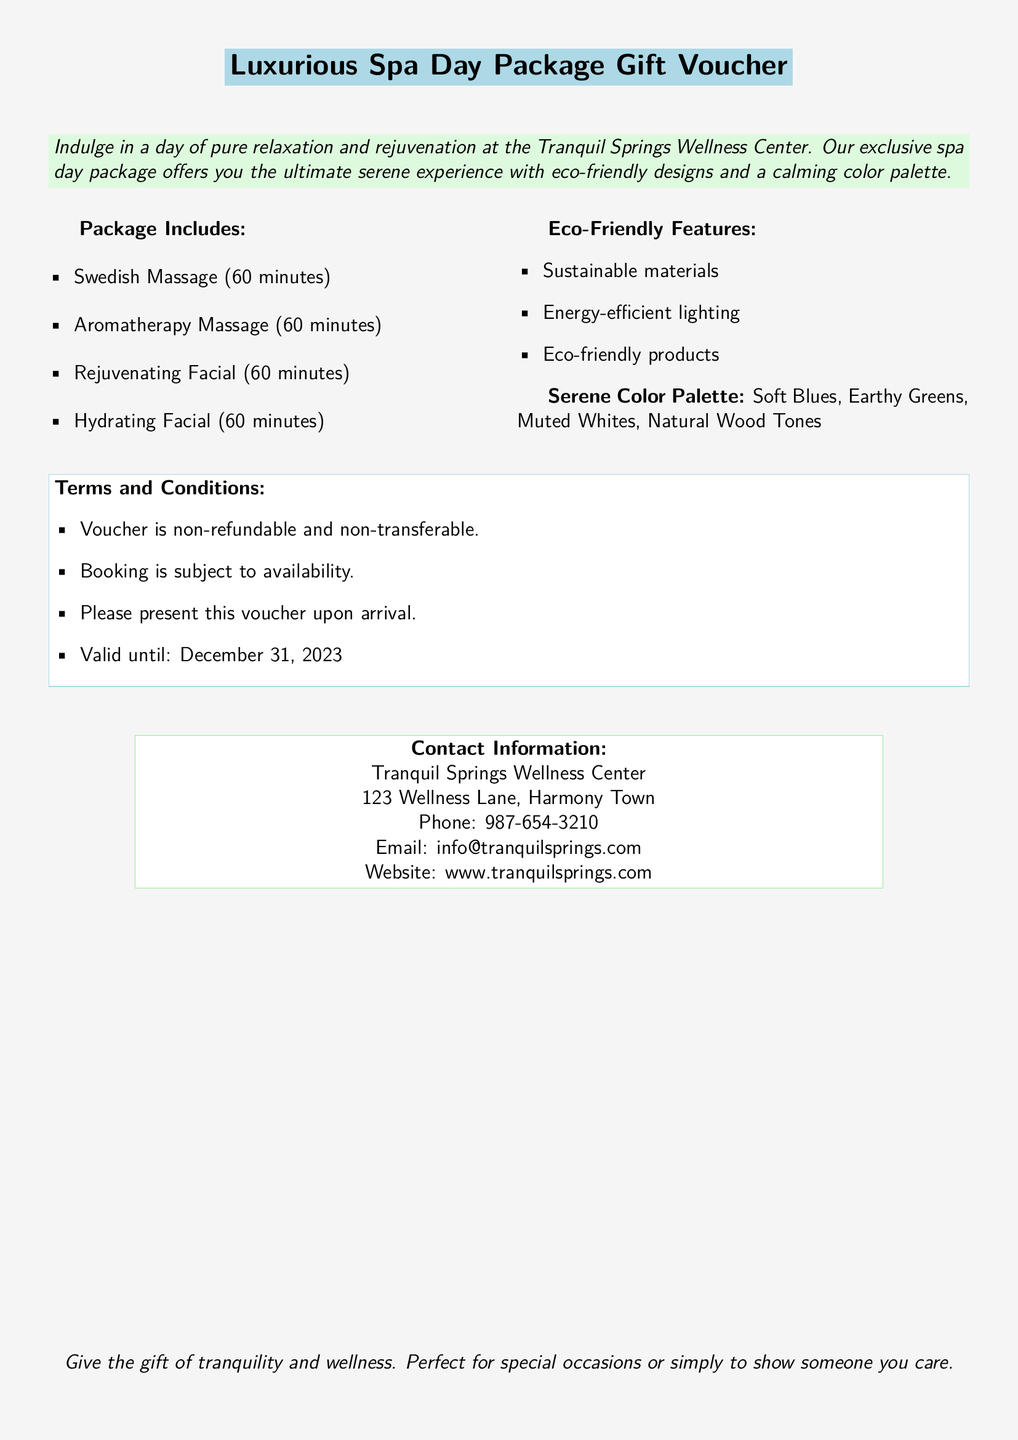What is the title of the voucher? The title of the voucher is clearly stated at the top of the document in large font.
Answer: Luxurious Spa Day Package Gift Voucher What is the valid until date? The document specifies the expiry date for the voucher in the terms and conditions section.
Answer: December 31, 2023 How long is the Swedish Massage? The duration of each massage is listed under the package includes section.
Answer: 60 minutes What eco-friendly feature is mentioned? The document lists multiple eco-friendly features, one of which is highlighted in the corresponding section.
Answer: Sustainable materials What types of facials are included in the package? The document specifies the types of facials available as part of the package in the package includes section.
Answer: Rejuvenating Facial, Hydrating Facial What kind of color palette is used for the spa? A description of the color palette is mentioned in a dedicated section of the document.
Answer: Soft Blues, Earthy Greens, Muted Whites, Natural Wood Tones Where is the wellness center located? The contact information section provides the address of the wellness center.
Answer: 123 Wellness Lane, Harmony Town What is the phone number for Tranquil Springs Wellness Center? The contact information section contains specific contact details, including the phone number.
Answer: 987-654-3210 Is the voucher refundable? The terms and conditions explicitly state the return policy for the voucher.
Answer: Non-refundable 